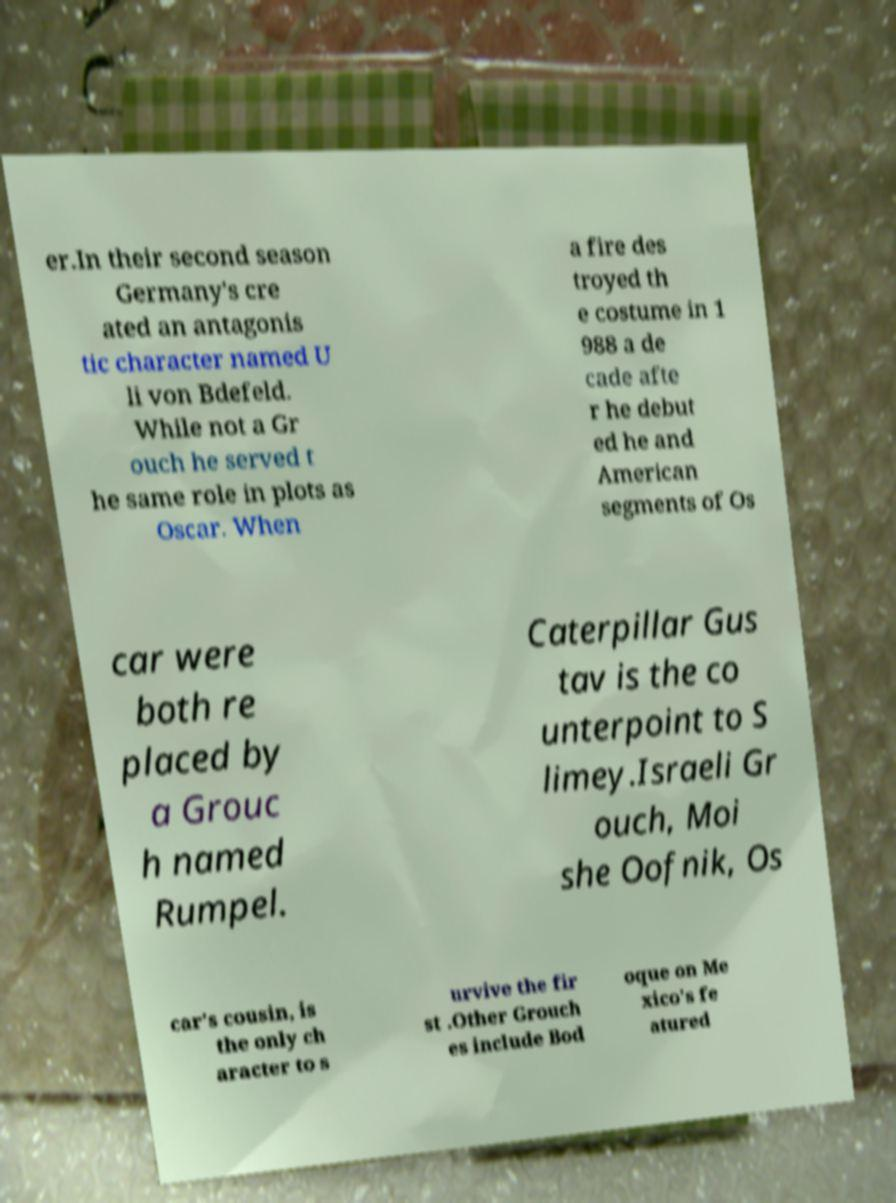Can you accurately transcribe the text from the provided image for me? er.In their second season Germany's cre ated an antagonis tic character named U li von Bdefeld. While not a Gr ouch he served t he same role in plots as Oscar. When a fire des troyed th e costume in 1 988 a de cade afte r he debut ed he and American segments of Os car were both re placed by a Grouc h named Rumpel. Caterpillar Gus tav is the co unterpoint to S limey.Israeli Gr ouch, Moi she Oofnik, Os car's cousin, is the only ch aracter to s urvive the fir st .Other Grouch es include Bod oque on Me xico's fe atured 